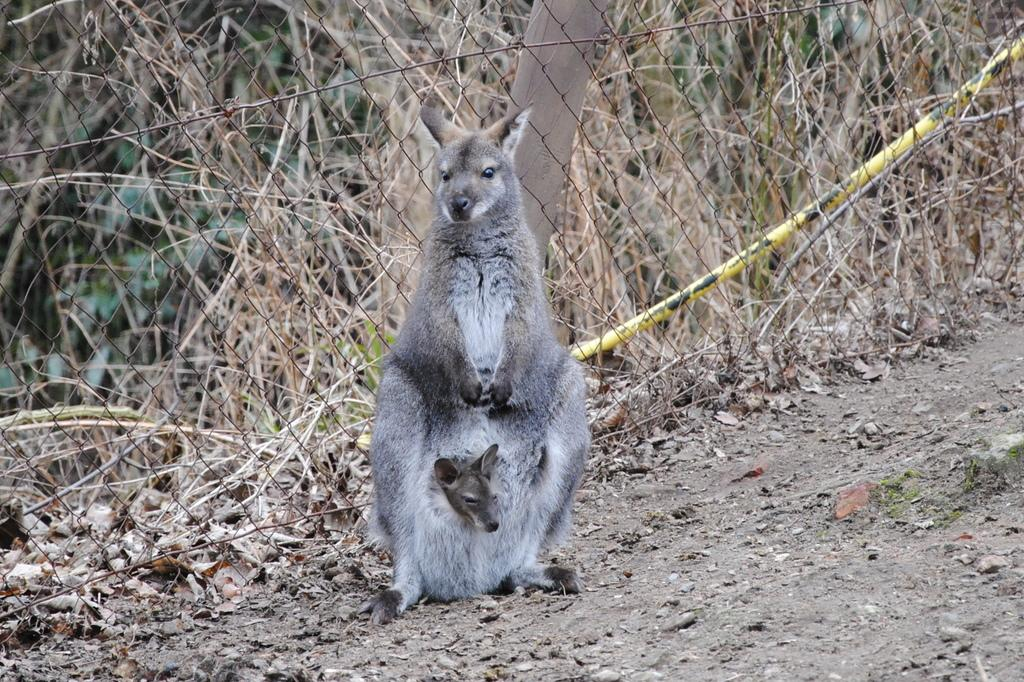How many animals can be seen in the image? There are two animals in the image. Where are the animals located? The animals are on the ground in the image. What else can be seen in the image besides the animals? There are plants and a fence in the image. What is covering the ground in the image? There are leaves on the ground in the image. What type of finger can be seen in the image? There are no fingers present in the image. What shape is the crowd in the image? There is no crowd present in the image. 